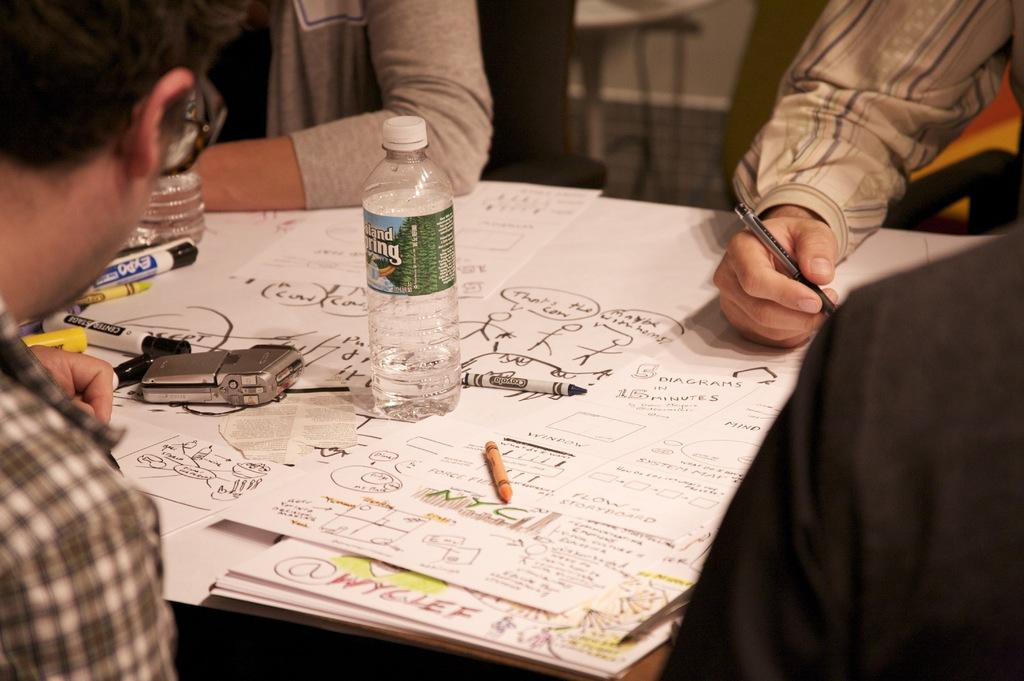Who is present in the image? There is a man in the image. What is the man doing with his hand? The man is resting his hand on a chart. Where is the chart located in the image? The chart is on the right side of the image. What else can be seen in the middle of the image? There is a bottle in the middle of the image. What type of creature is crawling on the chart in the image? There is no creature present on the chart or in the image. 